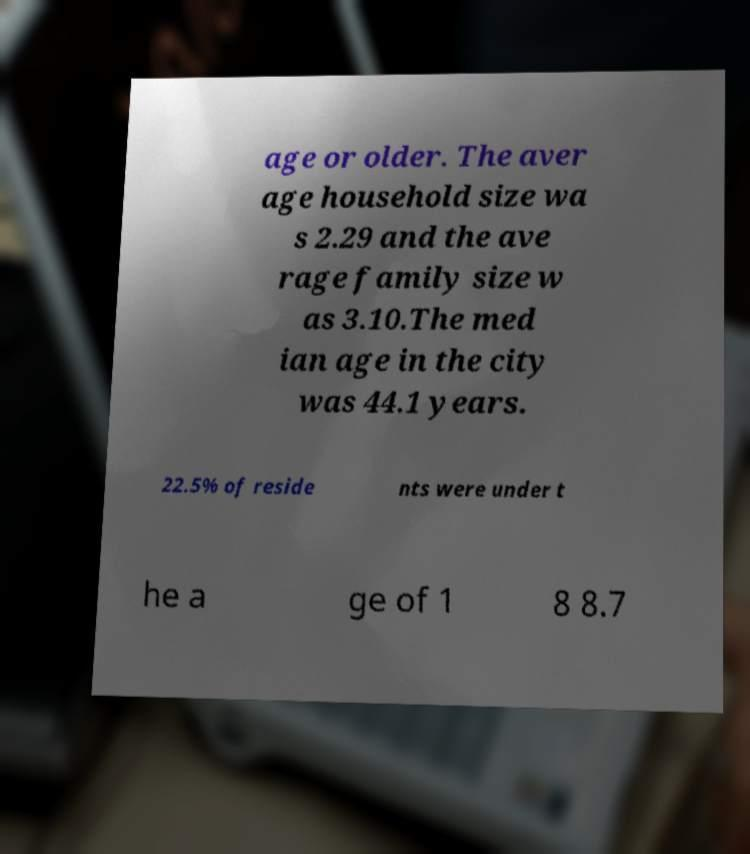For documentation purposes, I need the text within this image transcribed. Could you provide that? age or older. The aver age household size wa s 2.29 and the ave rage family size w as 3.10.The med ian age in the city was 44.1 years. 22.5% of reside nts were under t he a ge of 1 8 8.7 